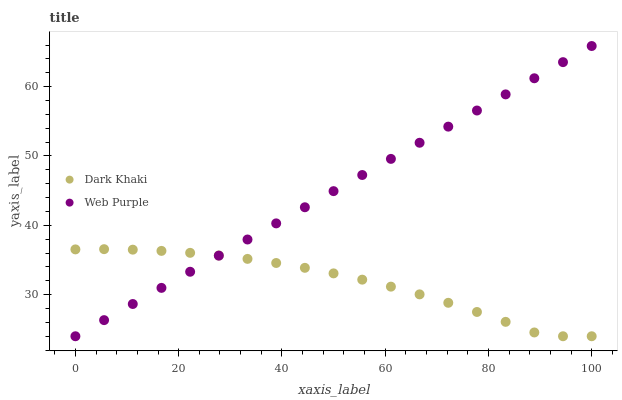Does Dark Khaki have the minimum area under the curve?
Answer yes or no. Yes. Does Web Purple have the maximum area under the curve?
Answer yes or no. Yes. Does Web Purple have the minimum area under the curve?
Answer yes or no. No. Is Web Purple the smoothest?
Answer yes or no. Yes. Is Dark Khaki the roughest?
Answer yes or no. Yes. Is Web Purple the roughest?
Answer yes or no. No. Does Dark Khaki have the lowest value?
Answer yes or no. Yes. Does Web Purple have the highest value?
Answer yes or no. Yes. Does Dark Khaki intersect Web Purple?
Answer yes or no. Yes. Is Dark Khaki less than Web Purple?
Answer yes or no. No. Is Dark Khaki greater than Web Purple?
Answer yes or no. No. 